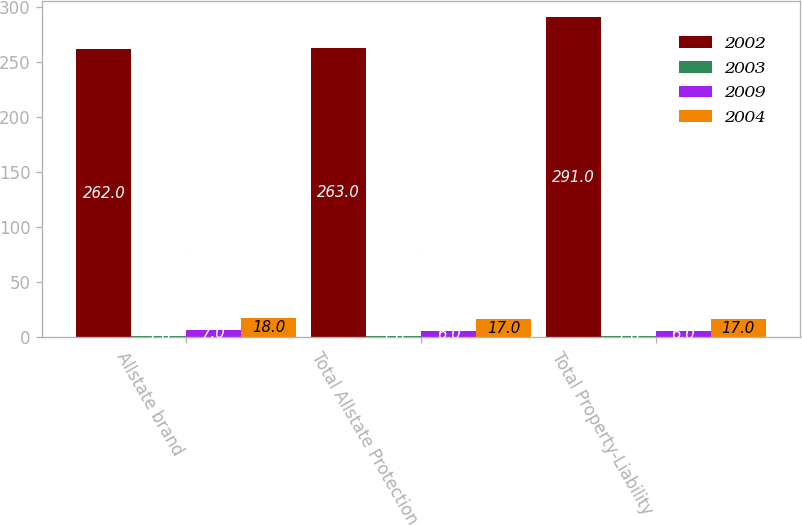<chart> <loc_0><loc_0><loc_500><loc_500><stacked_bar_chart><ecel><fcel>Allstate brand<fcel>Total Allstate Protection<fcel>Total Property-Liability<nl><fcel>2002<fcel>262<fcel>263<fcel>291<nl><fcel>2003<fcel>1<fcel>1<fcel>1<nl><fcel>2009<fcel>7<fcel>6<fcel>6<nl><fcel>2004<fcel>18<fcel>17<fcel>17<nl></chart> 